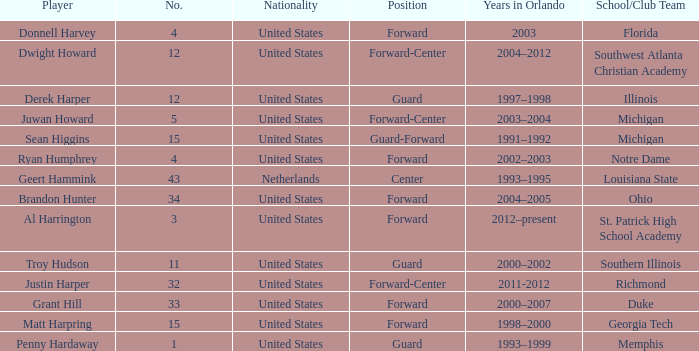Give me the full table as a dictionary. {'header': ['Player', 'No.', 'Nationality', 'Position', 'Years in Orlando', 'School/Club Team'], 'rows': [['Donnell Harvey', '4', 'United States', 'Forward', '2003', 'Florida'], ['Dwight Howard', '12', 'United States', 'Forward-Center', '2004–2012', 'Southwest Atlanta Christian Academy'], ['Derek Harper', '12', 'United States', 'Guard', '1997–1998', 'Illinois'], ['Juwan Howard', '5', 'United States', 'Forward-Center', '2003–2004', 'Michigan'], ['Sean Higgins', '15', 'United States', 'Guard-Forward', '1991–1992', 'Michigan'], ['Ryan Humphrey', '4', 'United States', 'Forward', '2002–2003', 'Notre Dame'], ['Geert Hammink', '43', 'Netherlands', 'Center', '1993–1995', 'Louisiana State'], ['Brandon Hunter', '34', 'United States', 'Forward', '2004–2005', 'Ohio'], ['Al Harrington', '3', 'United States', 'Forward', '2012–present', 'St. Patrick High School Academy'], ['Troy Hudson', '11', 'United States', 'Guard', '2000–2002', 'Southern Illinois'], ['Justin Harper', '32', 'United States', 'Forward-Center', '2011-2012', 'Richmond'], ['Grant Hill', '33', 'United States', 'Forward', '2000–2007', 'Duke'], ['Matt Harpring', '15', 'United States', 'Forward', '1998–2000', 'Georgia Tech'], ['Penny Hardaway', '1', 'United States', 'Guard', '1993–1999', 'Memphis']]} What jersey number did Al Harrington wear 3.0. 